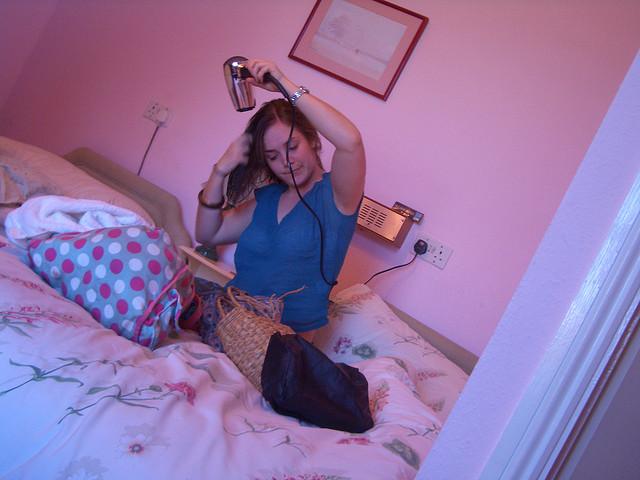What is the girl doing to her hair?
Give a very brief answer. Drying. Is she sitting on a bed?
Keep it brief. Yes. Is the girls wearing bangles?
Concise answer only. Yes. 